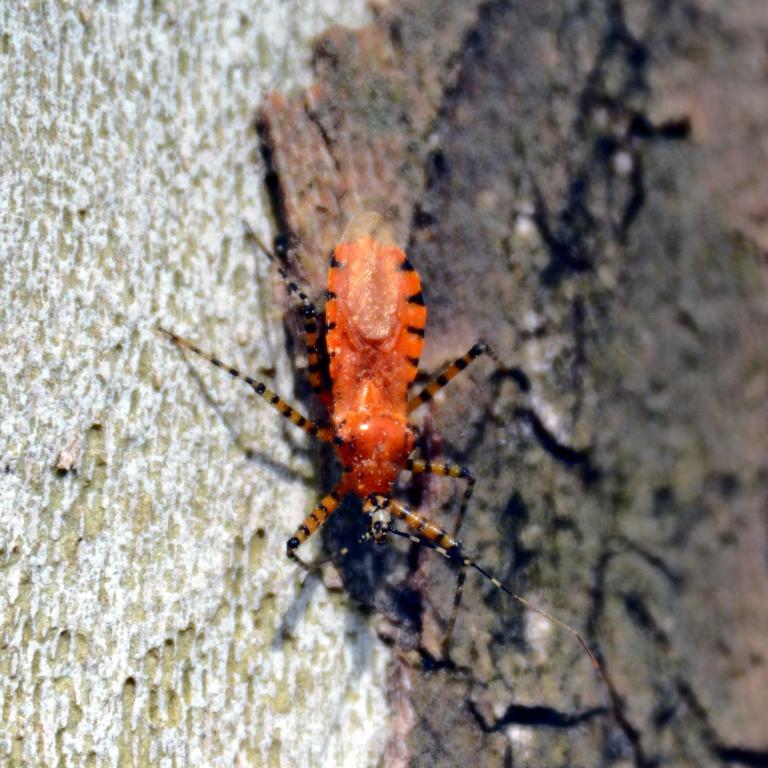Describe this image in one or two sentences. In this image we can see an insects on the wooden surface. 